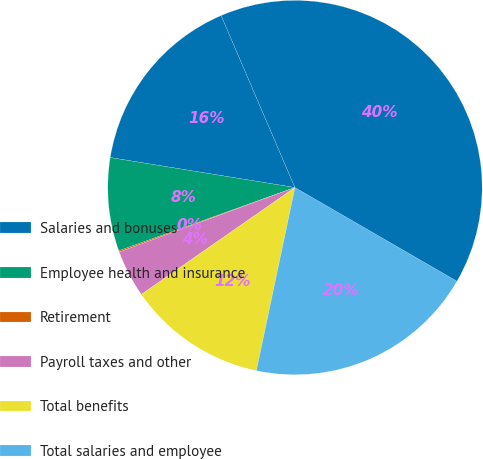Convert chart to OTSL. <chart><loc_0><loc_0><loc_500><loc_500><pie_chart><fcel>Salaries and bonuses<fcel>Employee health and insurance<fcel>Retirement<fcel>Payroll taxes and other<fcel>Total benefits<fcel>Total salaries and employee<fcel>Full-time equivalent employees<nl><fcel>15.99%<fcel>8.05%<fcel>0.11%<fcel>4.08%<fcel>12.02%<fcel>19.96%<fcel>39.8%<nl></chart> 